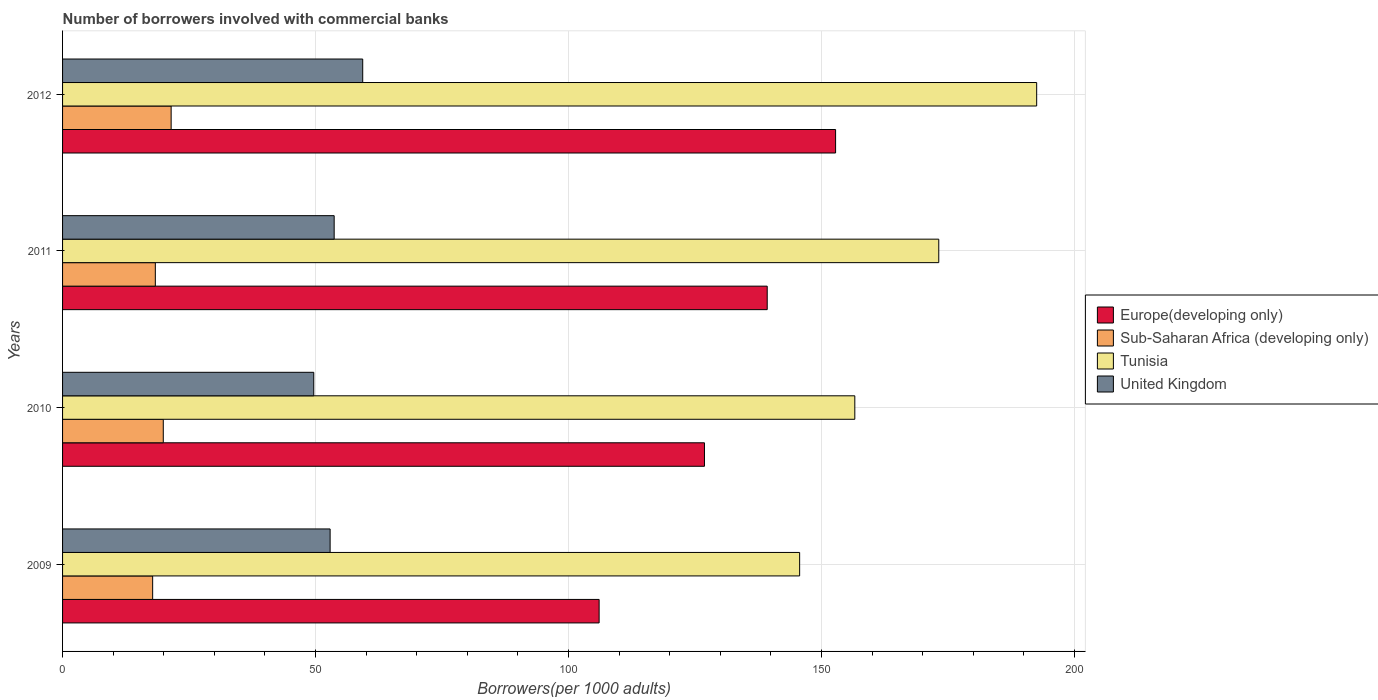How many different coloured bars are there?
Ensure brevity in your answer.  4. How many groups of bars are there?
Make the answer very short. 4. What is the number of borrowers involved with commercial banks in Europe(developing only) in 2011?
Provide a short and direct response. 139.27. Across all years, what is the maximum number of borrowers involved with commercial banks in United Kingdom?
Offer a very short reply. 59.32. Across all years, what is the minimum number of borrowers involved with commercial banks in Sub-Saharan Africa (developing only)?
Give a very brief answer. 17.81. In which year was the number of borrowers involved with commercial banks in Sub-Saharan Africa (developing only) minimum?
Keep it short and to the point. 2009. What is the total number of borrowers involved with commercial banks in Sub-Saharan Africa (developing only) in the graph?
Give a very brief answer. 77.5. What is the difference between the number of borrowers involved with commercial banks in Sub-Saharan Africa (developing only) in 2009 and that in 2012?
Your response must be concise. -3.65. What is the difference between the number of borrowers involved with commercial banks in Europe(developing only) in 2009 and the number of borrowers involved with commercial banks in Sub-Saharan Africa (developing only) in 2012?
Make the answer very short. 84.59. What is the average number of borrowers involved with commercial banks in Europe(developing only) per year?
Your response must be concise. 131.24. In the year 2011, what is the difference between the number of borrowers involved with commercial banks in United Kingdom and number of borrowers involved with commercial banks in Sub-Saharan Africa (developing only)?
Offer a very short reply. 35.35. What is the ratio of the number of borrowers involved with commercial banks in Tunisia in 2010 to that in 2012?
Your response must be concise. 0.81. What is the difference between the highest and the second highest number of borrowers involved with commercial banks in Europe(developing only)?
Your answer should be very brief. 13.51. What is the difference between the highest and the lowest number of borrowers involved with commercial banks in Tunisia?
Make the answer very short. 46.85. In how many years, is the number of borrowers involved with commercial banks in United Kingdom greater than the average number of borrowers involved with commercial banks in United Kingdom taken over all years?
Make the answer very short. 1. What does the 3rd bar from the top in 2012 represents?
Ensure brevity in your answer.  Sub-Saharan Africa (developing only). What does the 2nd bar from the bottom in 2010 represents?
Offer a very short reply. Sub-Saharan Africa (developing only). How many bars are there?
Your answer should be compact. 16. How many years are there in the graph?
Give a very brief answer. 4. What is the difference between two consecutive major ticks on the X-axis?
Give a very brief answer. 50. Are the values on the major ticks of X-axis written in scientific E-notation?
Provide a succinct answer. No. Where does the legend appear in the graph?
Provide a succinct answer. Center right. How many legend labels are there?
Make the answer very short. 4. What is the title of the graph?
Give a very brief answer. Number of borrowers involved with commercial banks. Does "Niger" appear as one of the legend labels in the graph?
Your answer should be very brief. No. What is the label or title of the X-axis?
Your answer should be compact. Borrowers(per 1000 adults). What is the Borrowers(per 1000 adults) of Europe(developing only) in 2009?
Offer a terse response. 106.05. What is the Borrowers(per 1000 adults) in Sub-Saharan Africa (developing only) in 2009?
Provide a succinct answer. 17.81. What is the Borrowers(per 1000 adults) of Tunisia in 2009?
Your response must be concise. 145.68. What is the Borrowers(per 1000 adults) in United Kingdom in 2009?
Keep it short and to the point. 52.88. What is the Borrowers(per 1000 adults) of Europe(developing only) in 2010?
Ensure brevity in your answer.  126.87. What is the Borrowers(per 1000 adults) of Sub-Saharan Africa (developing only) in 2010?
Your response must be concise. 19.9. What is the Borrowers(per 1000 adults) of Tunisia in 2010?
Give a very brief answer. 156.58. What is the Borrowers(per 1000 adults) in United Kingdom in 2010?
Your response must be concise. 49.65. What is the Borrowers(per 1000 adults) of Europe(developing only) in 2011?
Your answer should be compact. 139.27. What is the Borrowers(per 1000 adults) of Sub-Saharan Africa (developing only) in 2011?
Your answer should be very brief. 18.33. What is the Borrowers(per 1000 adults) of Tunisia in 2011?
Make the answer very short. 173.17. What is the Borrowers(per 1000 adults) in United Kingdom in 2011?
Ensure brevity in your answer.  53.68. What is the Borrowers(per 1000 adults) of Europe(developing only) in 2012?
Your answer should be very brief. 152.78. What is the Borrowers(per 1000 adults) in Sub-Saharan Africa (developing only) in 2012?
Your response must be concise. 21.46. What is the Borrowers(per 1000 adults) of Tunisia in 2012?
Provide a succinct answer. 192.52. What is the Borrowers(per 1000 adults) in United Kingdom in 2012?
Provide a succinct answer. 59.32. Across all years, what is the maximum Borrowers(per 1000 adults) in Europe(developing only)?
Offer a terse response. 152.78. Across all years, what is the maximum Borrowers(per 1000 adults) in Sub-Saharan Africa (developing only)?
Provide a short and direct response. 21.46. Across all years, what is the maximum Borrowers(per 1000 adults) of Tunisia?
Ensure brevity in your answer.  192.52. Across all years, what is the maximum Borrowers(per 1000 adults) in United Kingdom?
Offer a terse response. 59.32. Across all years, what is the minimum Borrowers(per 1000 adults) of Europe(developing only)?
Offer a very short reply. 106.05. Across all years, what is the minimum Borrowers(per 1000 adults) in Sub-Saharan Africa (developing only)?
Provide a succinct answer. 17.81. Across all years, what is the minimum Borrowers(per 1000 adults) in Tunisia?
Your answer should be very brief. 145.68. Across all years, what is the minimum Borrowers(per 1000 adults) in United Kingdom?
Provide a short and direct response. 49.65. What is the total Borrowers(per 1000 adults) in Europe(developing only) in the graph?
Make the answer very short. 524.96. What is the total Borrowers(per 1000 adults) of Sub-Saharan Africa (developing only) in the graph?
Offer a very short reply. 77.5. What is the total Borrowers(per 1000 adults) in Tunisia in the graph?
Keep it short and to the point. 667.95. What is the total Borrowers(per 1000 adults) of United Kingdom in the graph?
Ensure brevity in your answer.  215.53. What is the difference between the Borrowers(per 1000 adults) of Europe(developing only) in 2009 and that in 2010?
Make the answer very short. -20.82. What is the difference between the Borrowers(per 1000 adults) of Sub-Saharan Africa (developing only) in 2009 and that in 2010?
Give a very brief answer. -2.1. What is the difference between the Borrowers(per 1000 adults) of Tunisia in 2009 and that in 2010?
Your answer should be compact. -10.9. What is the difference between the Borrowers(per 1000 adults) of United Kingdom in 2009 and that in 2010?
Offer a terse response. 3.23. What is the difference between the Borrowers(per 1000 adults) of Europe(developing only) in 2009 and that in 2011?
Offer a terse response. -33.22. What is the difference between the Borrowers(per 1000 adults) of Sub-Saharan Africa (developing only) in 2009 and that in 2011?
Ensure brevity in your answer.  -0.53. What is the difference between the Borrowers(per 1000 adults) of Tunisia in 2009 and that in 2011?
Your answer should be very brief. -27.5. What is the difference between the Borrowers(per 1000 adults) in United Kingdom in 2009 and that in 2011?
Your answer should be compact. -0.8. What is the difference between the Borrowers(per 1000 adults) of Europe(developing only) in 2009 and that in 2012?
Your answer should be compact. -46.73. What is the difference between the Borrowers(per 1000 adults) in Sub-Saharan Africa (developing only) in 2009 and that in 2012?
Offer a terse response. -3.65. What is the difference between the Borrowers(per 1000 adults) in Tunisia in 2009 and that in 2012?
Your response must be concise. -46.85. What is the difference between the Borrowers(per 1000 adults) of United Kingdom in 2009 and that in 2012?
Provide a succinct answer. -6.44. What is the difference between the Borrowers(per 1000 adults) in Europe(developing only) in 2010 and that in 2011?
Give a very brief answer. -12.4. What is the difference between the Borrowers(per 1000 adults) in Sub-Saharan Africa (developing only) in 2010 and that in 2011?
Ensure brevity in your answer.  1.57. What is the difference between the Borrowers(per 1000 adults) of Tunisia in 2010 and that in 2011?
Give a very brief answer. -16.59. What is the difference between the Borrowers(per 1000 adults) in United Kingdom in 2010 and that in 2011?
Your answer should be very brief. -4.03. What is the difference between the Borrowers(per 1000 adults) of Europe(developing only) in 2010 and that in 2012?
Your response must be concise. -25.91. What is the difference between the Borrowers(per 1000 adults) of Sub-Saharan Africa (developing only) in 2010 and that in 2012?
Offer a very short reply. -1.56. What is the difference between the Borrowers(per 1000 adults) of Tunisia in 2010 and that in 2012?
Keep it short and to the point. -35.94. What is the difference between the Borrowers(per 1000 adults) in United Kingdom in 2010 and that in 2012?
Give a very brief answer. -9.67. What is the difference between the Borrowers(per 1000 adults) in Europe(developing only) in 2011 and that in 2012?
Make the answer very short. -13.51. What is the difference between the Borrowers(per 1000 adults) of Sub-Saharan Africa (developing only) in 2011 and that in 2012?
Provide a short and direct response. -3.13. What is the difference between the Borrowers(per 1000 adults) in Tunisia in 2011 and that in 2012?
Keep it short and to the point. -19.35. What is the difference between the Borrowers(per 1000 adults) in United Kingdom in 2011 and that in 2012?
Make the answer very short. -5.64. What is the difference between the Borrowers(per 1000 adults) of Europe(developing only) in 2009 and the Borrowers(per 1000 adults) of Sub-Saharan Africa (developing only) in 2010?
Your response must be concise. 86.14. What is the difference between the Borrowers(per 1000 adults) in Europe(developing only) in 2009 and the Borrowers(per 1000 adults) in Tunisia in 2010?
Give a very brief answer. -50.53. What is the difference between the Borrowers(per 1000 adults) in Europe(developing only) in 2009 and the Borrowers(per 1000 adults) in United Kingdom in 2010?
Your answer should be compact. 56.4. What is the difference between the Borrowers(per 1000 adults) of Sub-Saharan Africa (developing only) in 2009 and the Borrowers(per 1000 adults) of Tunisia in 2010?
Provide a succinct answer. -138.77. What is the difference between the Borrowers(per 1000 adults) of Sub-Saharan Africa (developing only) in 2009 and the Borrowers(per 1000 adults) of United Kingdom in 2010?
Your response must be concise. -31.84. What is the difference between the Borrowers(per 1000 adults) of Tunisia in 2009 and the Borrowers(per 1000 adults) of United Kingdom in 2010?
Your answer should be compact. 96.03. What is the difference between the Borrowers(per 1000 adults) in Europe(developing only) in 2009 and the Borrowers(per 1000 adults) in Sub-Saharan Africa (developing only) in 2011?
Make the answer very short. 87.71. What is the difference between the Borrowers(per 1000 adults) of Europe(developing only) in 2009 and the Borrowers(per 1000 adults) of Tunisia in 2011?
Provide a short and direct response. -67.13. What is the difference between the Borrowers(per 1000 adults) of Europe(developing only) in 2009 and the Borrowers(per 1000 adults) of United Kingdom in 2011?
Offer a very short reply. 52.37. What is the difference between the Borrowers(per 1000 adults) of Sub-Saharan Africa (developing only) in 2009 and the Borrowers(per 1000 adults) of Tunisia in 2011?
Keep it short and to the point. -155.37. What is the difference between the Borrowers(per 1000 adults) in Sub-Saharan Africa (developing only) in 2009 and the Borrowers(per 1000 adults) in United Kingdom in 2011?
Make the answer very short. -35.87. What is the difference between the Borrowers(per 1000 adults) of Tunisia in 2009 and the Borrowers(per 1000 adults) of United Kingdom in 2011?
Your answer should be very brief. 92. What is the difference between the Borrowers(per 1000 adults) of Europe(developing only) in 2009 and the Borrowers(per 1000 adults) of Sub-Saharan Africa (developing only) in 2012?
Keep it short and to the point. 84.59. What is the difference between the Borrowers(per 1000 adults) of Europe(developing only) in 2009 and the Borrowers(per 1000 adults) of Tunisia in 2012?
Give a very brief answer. -86.48. What is the difference between the Borrowers(per 1000 adults) of Europe(developing only) in 2009 and the Borrowers(per 1000 adults) of United Kingdom in 2012?
Offer a terse response. 46.73. What is the difference between the Borrowers(per 1000 adults) of Sub-Saharan Africa (developing only) in 2009 and the Borrowers(per 1000 adults) of Tunisia in 2012?
Keep it short and to the point. -174.72. What is the difference between the Borrowers(per 1000 adults) of Sub-Saharan Africa (developing only) in 2009 and the Borrowers(per 1000 adults) of United Kingdom in 2012?
Your response must be concise. -41.52. What is the difference between the Borrowers(per 1000 adults) in Tunisia in 2009 and the Borrowers(per 1000 adults) in United Kingdom in 2012?
Keep it short and to the point. 86.35. What is the difference between the Borrowers(per 1000 adults) of Europe(developing only) in 2010 and the Borrowers(per 1000 adults) of Sub-Saharan Africa (developing only) in 2011?
Offer a very short reply. 108.53. What is the difference between the Borrowers(per 1000 adults) in Europe(developing only) in 2010 and the Borrowers(per 1000 adults) in Tunisia in 2011?
Your answer should be very brief. -46.3. What is the difference between the Borrowers(per 1000 adults) of Europe(developing only) in 2010 and the Borrowers(per 1000 adults) of United Kingdom in 2011?
Your response must be concise. 73.19. What is the difference between the Borrowers(per 1000 adults) of Sub-Saharan Africa (developing only) in 2010 and the Borrowers(per 1000 adults) of Tunisia in 2011?
Provide a short and direct response. -153.27. What is the difference between the Borrowers(per 1000 adults) of Sub-Saharan Africa (developing only) in 2010 and the Borrowers(per 1000 adults) of United Kingdom in 2011?
Offer a terse response. -33.78. What is the difference between the Borrowers(per 1000 adults) in Tunisia in 2010 and the Borrowers(per 1000 adults) in United Kingdom in 2011?
Offer a terse response. 102.9. What is the difference between the Borrowers(per 1000 adults) of Europe(developing only) in 2010 and the Borrowers(per 1000 adults) of Sub-Saharan Africa (developing only) in 2012?
Provide a succinct answer. 105.41. What is the difference between the Borrowers(per 1000 adults) of Europe(developing only) in 2010 and the Borrowers(per 1000 adults) of Tunisia in 2012?
Offer a very short reply. -65.66. What is the difference between the Borrowers(per 1000 adults) of Europe(developing only) in 2010 and the Borrowers(per 1000 adults) of United Kingdom in 2012?
Your answer should be compact. 67.55. What is the difference between the Borrowers(per 1000 adults) in Sub-Saharan Africa (developing only) in 2010 and the Borrowers(per 1000 adults) in Tunisia in 2012?
Your answer should be compact. -172.62. What is the difference between the Borrowers(per 1000 adults) of Sub-Saharan Africa (developing only) in 2010 and the Borrowers(per 1000 adults) of United Kingdom in 2012?
Your response must be concise. -39.42. What is the difference between the Borrowers(per 1000 adults) in Tunisia in 2010 and the Borrowers(per 1000 adults) in United Kingdom in 2012?
Make the answer very short. 97.26. What is the difference between the Borrowers(per 1000 adults) in Europe(developing only) in 2011 and the Borrowers(per 1000 adults) in Sub-Saharan Africa (developing only) in 2012?
Your answer should be compact. 117.81. What is the difference between the Borrowers(per 1000 adults) of Europe(developing only) in 2011 and the Borrowers(per 1000 adults) of Tunisia in 2012?
Your response must be concise. -53.26. What is the difference between the Borrowers(per 1000 adults) of Europe(developing only) in 2011 and the Borrowers(per 1000 adults) of United Kingdom in 2012?
Your response must be concise. 79.95. What is the difference between the Borrowers(per 1000 adults) in Sub-Saharan Africa (developing only) in 2011 and the Borrowers(per 1000 adults) in Tunisia in 2012?
Provide a short and direct response. -174.19. What is the difference between the Borrowers(per 1000 adults) of Sub-Saharan Africa (developing only) in 2011 and the Borrowers(per 1000 adults) of United Kingdom in 2012?
Your answer should be very brief. -40.99. What is the difference between the Borrowers(per 1000 adults) of Tunisia in 2011 and the Borrowers(per 1000 adults) of United Kingdom in 2012?
Your answer should be compact. 113.85. What is the average Borrowers(per 1000 adults) of Europe(developing only) per year?
Keep it short and to the point. 131.24. What is the average Borrowers(per 1000 adults) in Sub-Saharan Africa (developing only) per year?
Ensure brevity in your answer.  19.38. What is the average Borrowers(per 1000 adults) of Tunisia per year?
Make the answer very short. 166.99. What is the average Borrowers(per 1000 adults) in United Kingdom per year?
Your answer should be very brief. 53.88. In the year 2009, what is the difference between the Borrowers(per 1000 adults) in Europe(developing only) and Borrowers(per 1000 adults) in Sub-Saharan Africa (developing only)?
Provide a succinct answer. 88.24. In the year 2009, what is the difference between the Borrowers(per 1000 adults) in Europe(developing only) and Borrowers(per 1000 adults) in Tunisia?
Your response must be concise. -39.63. In the year 2009, what is the difference between the Borrowers(per 1000 adults) in Europe(developing only) and Borrowers(per 1000 adults) in United Kingdom?
Provide a short and direct response. 53.17. In the year 2009, what is the difference between the Borrowers(per 1000 adults) in Sub-Saharan Africa (developing only) and Borrowers(per 1000 adults) in Tunisia?
Keep it short and to the point. -127.87. In the year 2009, what is the difference between the Borrowers(per 1000 adults) in Sub-Saharan Africa (developing only) and Borrowers(per 1000 adults) in United Kingdom?
Provide a short and direct response. -35.08. In the year 2009, what is the difference between the Borrowers(per 1000 adults) in Tunisia and Borrowers(per 1000 adults) in United Kingdom?
Provide a succinct answer. 92.79. In the year 2010, what is the difference between the Borrowers(per 1000 adults) in Europe(developing only) and Borrowers(per 1000 adults) in Sub-Saharan Africa (developing only)?
Provide a succinct answer. 106.96. In the year 2010, what is the difference between the Borrowers(per 1000 adults) in Europe(developing only) and Borrowers(per 1000 adults) in Tunisia?
Offer a very short reply. -29.71. In the year 2010, what is the difference between the Borrowers(per 1000 adults) of Europe(developing only) and Borrowers(per 1000 adults) of United Kingdom?
Keep it short and to the point. 77.22. In the year 2010, what is the difference between the Borrowers(per 1000 adults) in Sub-Saharan Africa (developing only) and Borrowers(per 1000 adults) in Tunisia?
Make the answer very short. -136.68. In the year 2010, what is the difference between the Borrowers(per 1000 adults) in Sub-Saharan Africa (developing only) and Borrowers(per 1000 adults) in United Kingdom?
Your answer should be compact. -29.74. In the year 2010, what is the difference between the Borrowers(per 1000 adults) of Tunisia and Borrowers(per 1000 adults) of United Kingdom?
Your response must be concise. 106.93. In the year 2011, what is the difference between the Borrowers(per 1000 adults) of Europe(developing only) and Borrowers(per 1000 adults) of Sub-Saharan Africa (developing only)?
Ensure brevity in your answer.  120.93. In the year 2011, what is the difference between the Borrowers(per 1000 adults) in Europe(developing only) and Borrowers(per 1000 adults) in Tunisia?
Your answer should be compact. -33.91. In the year 2011, what is the difference between the Borrowers(per 1000 adults) of Europe(developing only) and Borrowers(per 1000 adults) of United Kingdom?
Provide a short and direct response. 85.59. In the year 2011, what is the difference between the Borrowers(per 1000 adults) in Sub-Saharan Africa (developing only) and Borrowers(per 1000 adults) in Tunisia?
Provide a succinct answer. -154.84. In the year 2011, what is the difference between the Borrowers(per 1000 adults) of Sub-Saharan Africa (developing only) and Borrowers(per 1000 adults) of United Kingdom?
Offer a terse response. -35.35. In the year 2011, what is the difference between the Borrowers(per 1000 adults) of Tunisia and Borrowers(per 1000 adults) of United Kingdom?
Your answer should be compact. 119.49. In the year 2012, what is the difference between the Borrowers(per 1000 adults) in Europe(developing only) and Borrowers(per 1000 adults) in Sub-Saharan Africa (developing only)?
Offer a terse response. 131.32. In the year 2012, what is the difference between the Borrowers(per 1000 adults) in Europe(developing only) and Borrowers(per 1000 adults) in Tunisia?
Your answer should be compact. -39.74. In the year 2012, what is the difference between the Borrowers(per 1000 adults) of Europe(developing only) and Borrowers(per 1000 adults) of United Kingdom?
Your answer should be compact. 93.46. In the year 2012, what is the difference between the Borrowers(per 1000 adults) in Sub-Saharan Africa (developing only) and Borrowers(per 1000 adults) in Tunisia?
Give a very brief answer. -171.06. In the year 2012, what is the difference between the Borrowers(per 1000 adults) in Sub-Saharan Africa (developing only) and Borrowers(per 1000 adults) in United Kingdom?
Give a very brief answer. -37.86. In the year 2012, what is the difference between the Borrowers(per 1000 adults) in Tunisia and Borrowers(per 1000 adults) in United Kingdom?
Keep it short and to the point. 133.2. What is the ratio of the Borrowers(per 1000 adults) of Europe(developing only) in 2009 to that in 2010?
Offer a very short reply. 0.84. What is the ratio of the Borrowers(per 1000 adults) of Sub-Saharan Africa (developing only) in 2009 to that in 2010?
Your response must be concise. 0.89. What is the ratio of the Borrowers(per 1000 adults) in Tunisia in 2009 to that in 2010?
Ensure brevity in your answer.  0.93. What is the ratio of the Borrowers(per 1000 adults) in United Kingdom in 2009 to that in 2010?
Provide a succinct answer. 1.07. What is the ratio of the Borrowers(per 1000 adults) in Europe(developing only) in 2009 to that in 2011?
Give a very brief answer. 0.76. What is the ratio of the Borrowers(per 1000 adults) in Sub-Saharan Africa (developing only) in 2009 to that in 2011?
Your answer should be very brief. 0.97. What is the ratio of the Borrowers(per 1000 adults) in Tunisia in 2009 to that in 2011?
Your answer should be very brief. 0.84. What is the ratio of the Borrowers(per 1000 adults) in United Kingdom in 2009 to that in 2011?
Provide a short and direct response. 0.99. What is the ratio of the Borrowers(per 1000 adults) of Europe(developing only) in 2009 to that in 2012?
Make the answer very short. 0.69. What is the ratio of the Borrowers(per 1000 adults) in Sub-Saharan Africa (developing only) in 2009 to that in 2012?
Offer a terse response. 0.83. What is the ratio of the Borrowers(per 1000 adults) of Tunisia in 2009 to that in 2012?
Make the answer very short. 0.76. What is the ratio of the Borrowers(per 1000 adults) in United Kingdom in 2009 to that in 2012?
Your response must be concise. 0.89. What is the ratio of the Borrowers(per 1000 adults) in Europe(developing only) in 2010 to that in 2011?
Your response must be concise. 0.91. What is the ratio of the Borrowers(per 1000 adults) in Sub-Saharan Africa (developing only) in 2010 to that in 2011?
Keep it short and to the point. 1.09. What is the ratio of the Borrowers(per 1000 adults) in Tunisia in 2010 to that in 2011?
Keep it short and to the point. 0.9. What is the ratio of the Borrowers(per 1000 adults) of United Kingdom in 2010 to that in 2011?
Give a very brief answer. 0.92. What is the ratio of the Borrowers(per 1000 adults) in Europe(developing only) in 2010 to that in 2012?
Make the answer very short. 0.83. What is the ratio of the Borrowers(per 1000 adults) of Sub-Saharan Africa (developing only) in 2010 to that in 2012?
Your response must be concise. 0.93. What is the ratio of the Borrowers(per 1000 adults) in Tunisia in 2010 to that in 2012?
Keep it short and to the point. 0.81. What is the ratio of the Borrowers(per 1000 adults) in United Kingdom in 2010 to that in 2012?
Provide a short and direct response. 0.84. What is the ratio of the Borrowers(per 1000 adults) in Europe(developing only) in 2011 to that in 2012?
Keep it short and to the point. 0.91. What is the ratio of the Borrowers(per 1000 adults) of Sub-Saharan Africa (developing only) in 2011 to that in 2012?
Ensure brevity in your answer.  0.85. What is the ratio of the Borrowers(per 1000 adults) in Tunisia in 2011 to that in 2012?
Your answer should be compact. 0.9. What is the ratio of the Borrowers(per 1000 adults) of United Kingdom in 2011 to that in 2012?
Ensure brevity in your answer.  0.9. What is the difference between the highest and the second highest Borrowers(per 1000 adults) in Europe(developing only)?
Your response must be concise. 13.51. What is the difference between the highest and the second highest Borrowers(per 1000 adults) of Sub-Saharan Africa (developing only)?
Provide a short and direct response. 1.56. What is the difference between the highest and the second highest Borrowers(per 1000 adults) in Tunisia?
Give a very brief answer. 19.35. What is the difference between the highest and the second highest Borrowers(per 1000 adults) in United Kingdom?
Provide a short and direct response. 5.64. What is the difference between the highest and the lowest Borrowers(per 1000 adults) of Europe(developing only)?
Keep it short and to the point. 46.73. What is the difference between the highest and the lowest Borrowers(per 1000 adults) of Sub-Saharan Africa (developing only)?
Make the answer very short. 3.65. What is the difference between the highest and the lowest Borrowers(per 1000 adults) in Tunisia?
Your answer should be very brief. 46.85. What is the difference between the highest and the lowest Borrowers(per 1000 adults) in United Kingdom?
Give a very brief answer. 9.67. 